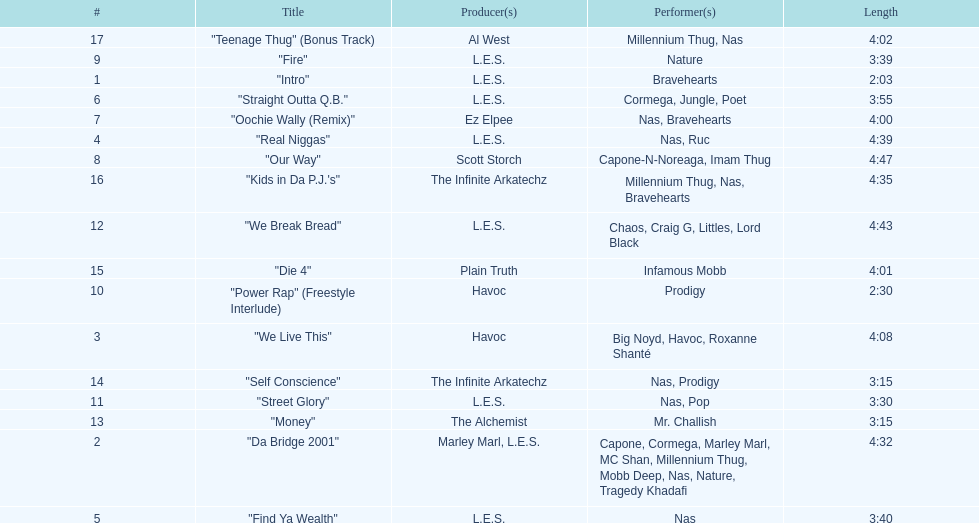What performers were in the last track? Millennium Thug, Nas. 